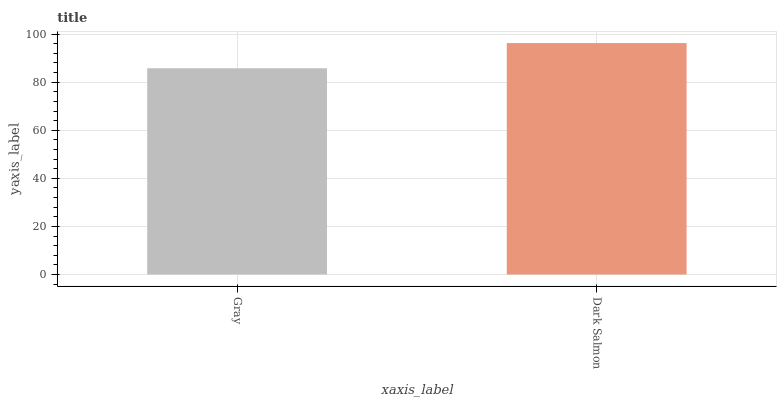Is Gray the minimum?
Answer yes or no. Yes. Is Dark Salmon the maximum?
Answer yes or no. Yes. Is Dark Salmon the minimum?
Answer yes or no. No. Is Dark Salmon greater than Gray?
Answer yes or no. Yes. Is Gray less than Dark Salmon?
Answer yes or no. Yes. Is Gray greater than Dark Salmon?
Answer yes or no. No. Is Dark Salmon less than Gray?
Answer yes or no. No. Is Dark Salmon the high median?
Answer yes or no. Yes. Is Gray the low median?
Answer yes or no. Yes. Is Gray the high median?
Answer yes or no. No. Is Dark Salmon the low median?
Answer yes or no. No. 